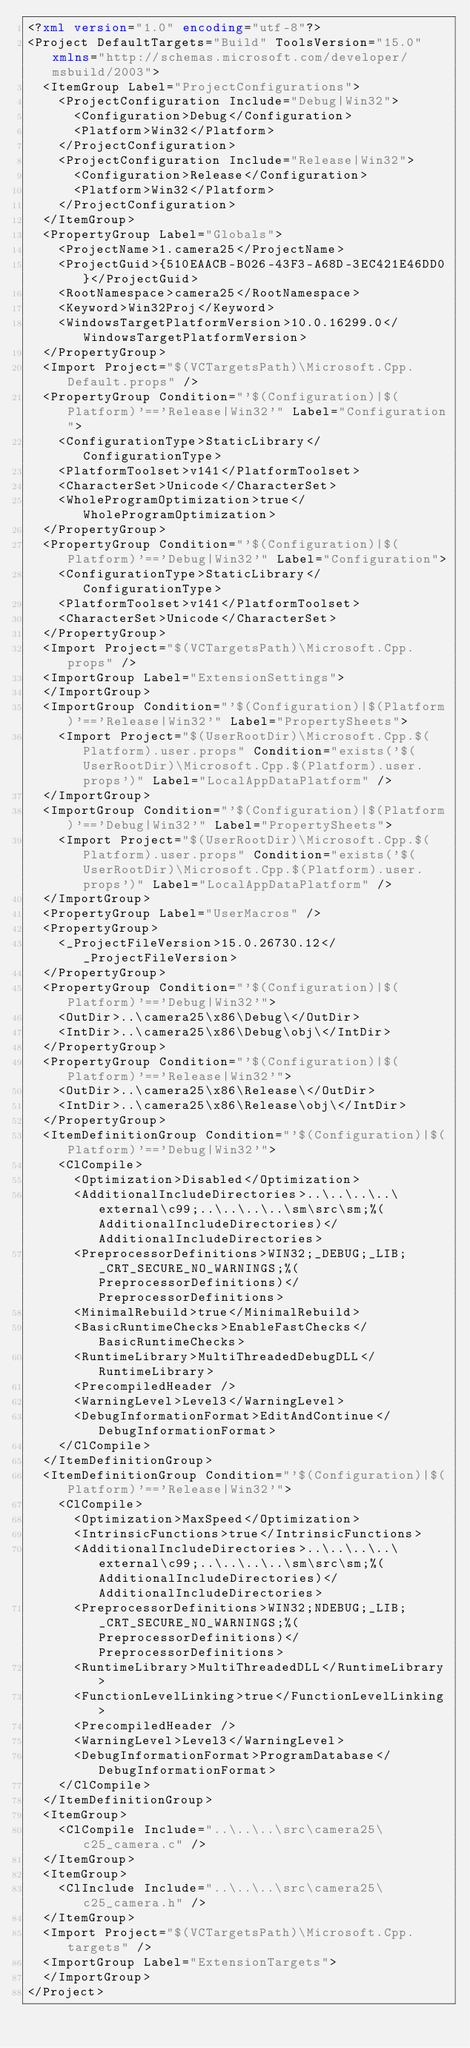<code> <loc_0><loc_0><loc_500><loc_500><_XML_><?xml version="1.0" encoding="utf-8"?>
<Project DefaultTargets="Build" ToolsVersion="15.0" xmlns="http://schemas.microsoft.com/developer/msbuild/2003">
  <ItemGroup Label="ProjectConfigurations">
    <ProjectConfiguration Include="Debug|Win32">
      <Configuration>Debug</Configuration>
      <Platform>Win32</Platform>
    </ProjectConfiguration>
    <ProjectConfiguration Include="Release|Win32">
      <Configuration>Release</Configuration>
      <Platform>Win32</Platform>
    </ProjectConfiguration>
  </ItemGroup>
  <PropertyGroup Label="Globals">
    <ProjectName>1.camera25</ProjectName>
    <ProjectGuid>{510EAACB-B026-43F3-A68D-3EC421E46DD0}</ProjectGuid>
    <RootNamespace>camera25</RootNamespace>
    <Keyword>Win32Proj</Keyword>
    <WindowsTargetPlatformVersion>10.0.16299.0</WindowsTargetPlatformVersion>
  </PropertyGroup>
  <Import Project="$(VCTargetsPath)\Microsoft.Cpp.Default.props" />
  <PropertyGroup Condition="'$(Configuration)|$(Platform)'=='Release|Win32'" Label="Configuration">
    <ConfigurationType>StaticLibrary</ConfigurationType>
    <PlatformToolset>v141</PlatformToolset>
    <CharacterSet>Unicode</CharacterSet>
    <WholeProgramOptimization>true</WholeProgramOptimization>
  </PropertyGroup>
  <PropertyGroup Condition="'$(Configuration)|$(Platform)'=='Debug|Win32'" Label="Configuration">
    <ConfigurationType>StaticLibrary</ConfigurationType>
    <PlatformToolset>v141</PlatformToolset>
    <CharacterSet>Unicode</CharacterSet>
  </PropertyGroup>
  <Import Project="$(VCTargetsPath)\Microsoft.Cpp.props" />
  <ImportGroup Label="ExtensionSettings">
  </ImportGroup>
  <ImportGroup Condition="'$(Configuration)|$(Platform)'=='Release|Win32'" Label="PropertySheets">
    <Import Project="$(UserRootDir)\Microsoft.Cpp.$(Platform).user.props" Condition="exists('$(UserRootDir)\Microsoft.Cpp.$(Platform).user.props')" Label="LocalAppDataPlatform" />
  </ImportGroup>
  <ImportGroup Condition="'$(Configuration)|$(Platform)'=='Debug|Win32'" Label="PropertySheets">
    <Import Project="$(UserRootDir)\Microsoft.Cpp.$(Platform).user.props" Condition="exists('$(UserRootDir)\Microsoft.Cpp.$(Platform).user.props')" Label="LocalAppDataPlatform" />
  </ImportGroup>
  <PropertyGroup Label="UserMacros" />
  <PropertyGroup>
    <_ProjectFileVersion>15.0.26730.12</_ProjectFileVersion>
  </PropertyGroup>
  <PropertyGroup Condition="'$(Configuration)|$(Platform)'=='Debug|Win32'">
    <OutDir>..\camera25\x86\Debug\</OutDir>
    <IntDir>..\camera25\x86\Debug\obj\</IntDir>
  </PropertyGroup>
  <PropertyGroup Condition="'$(Configuration)|$(Platform)'=='Release|Win32'">
    <OutDir>..\camera25\x86\Release\</OutDir>
    <IntDir>..\camera25\x86\Release\obj\</IntDir>
  </PropertyGroup>
  <ItemDefinitionGroup Condition="'$(Configuration)|$(Platform)'=='Debug|Win32'">
    <ClCompile>
      <Optimization>Disabled</Optimization>
      <AdditionalIncludeDirectories>..\..\..\..\external\c99;..\..\..\..\sm\src\sm;%(AdditionalIncludeDirectories)</AdditionalIncludeDirectories>
      <PreprocessorDefinitions>WIN32;_DEBUG;_LIB;_CRT_SECURE_NO_WARNINGS;%(PreprocessorDefinitions)</PreprocessorDefinitions>
      <MinimalRebuild>true</MinimalRebuild>
      <BasicRuntimeChecks>EnableFastChecks</BasicRuntimeChecks>
      <RuntimeLibrary>MultiThreadedDebugDLL</RuntimeLibrary>
      <PrecompiledHeader />
      <WarningLevel>Level3</WarningLevel>
      <DebugInformationFormat>EditAndContinue</DebugInformationFormat>
    </ClCompile>
  </ItemDefinitionGroup>
  <ItemDefinitionGroup Condition="'$(Configuration)|$(Platform)'=='Release|Win32'">
    <ClCompile>
      <Optimization>MaxSpeed</Optimization>
      <IntrinsicFunctions>true</IntrinsicFunctions>
      <AdditionalIncludeDirectories>..\..\..\..\external\c99;..\..\..\..\sm\src\sm;%(AdditionalIncludeDirectories)</AdditionalIncludeDirectories>
      <PreprocessorDefinitions>WIN32;NDEBUG;_LIB;_CRT_SECURE_NO_WARNINGS;%(PreprocessorDefinitions)</PreprocessorDefinitions>
      <RuntimeLibrary>MultiThreadedDLL</RuntimeLibrary>
      <FunctionLevelLinking>true</FunctionLevelLinking>
      <PrecompiledHeader />
      <WarningLevel>Level3</WarningLevel>
      <DebugInformationFormat>ProgramDatabase</DebugInformationFormat>
    </ClCompile>
  </ItemDefinitionGroup>
  <ItemGroup>
    <ClCompile Include="..\..\..\src\camera25\c25_camera.c" />
  </ItemGroup>
  <ItemGroup>
    <ClInclude Include="..\..\..\src\camera25\c25_camera.h" />
  </ItemGroup>
  <Import Project="$(VCTargetsPath)\Microsoft.Cpp.targets" />
  <ImportGroup Label="ExtensionTargets">
  </ImportGroup>
</Project></code> 